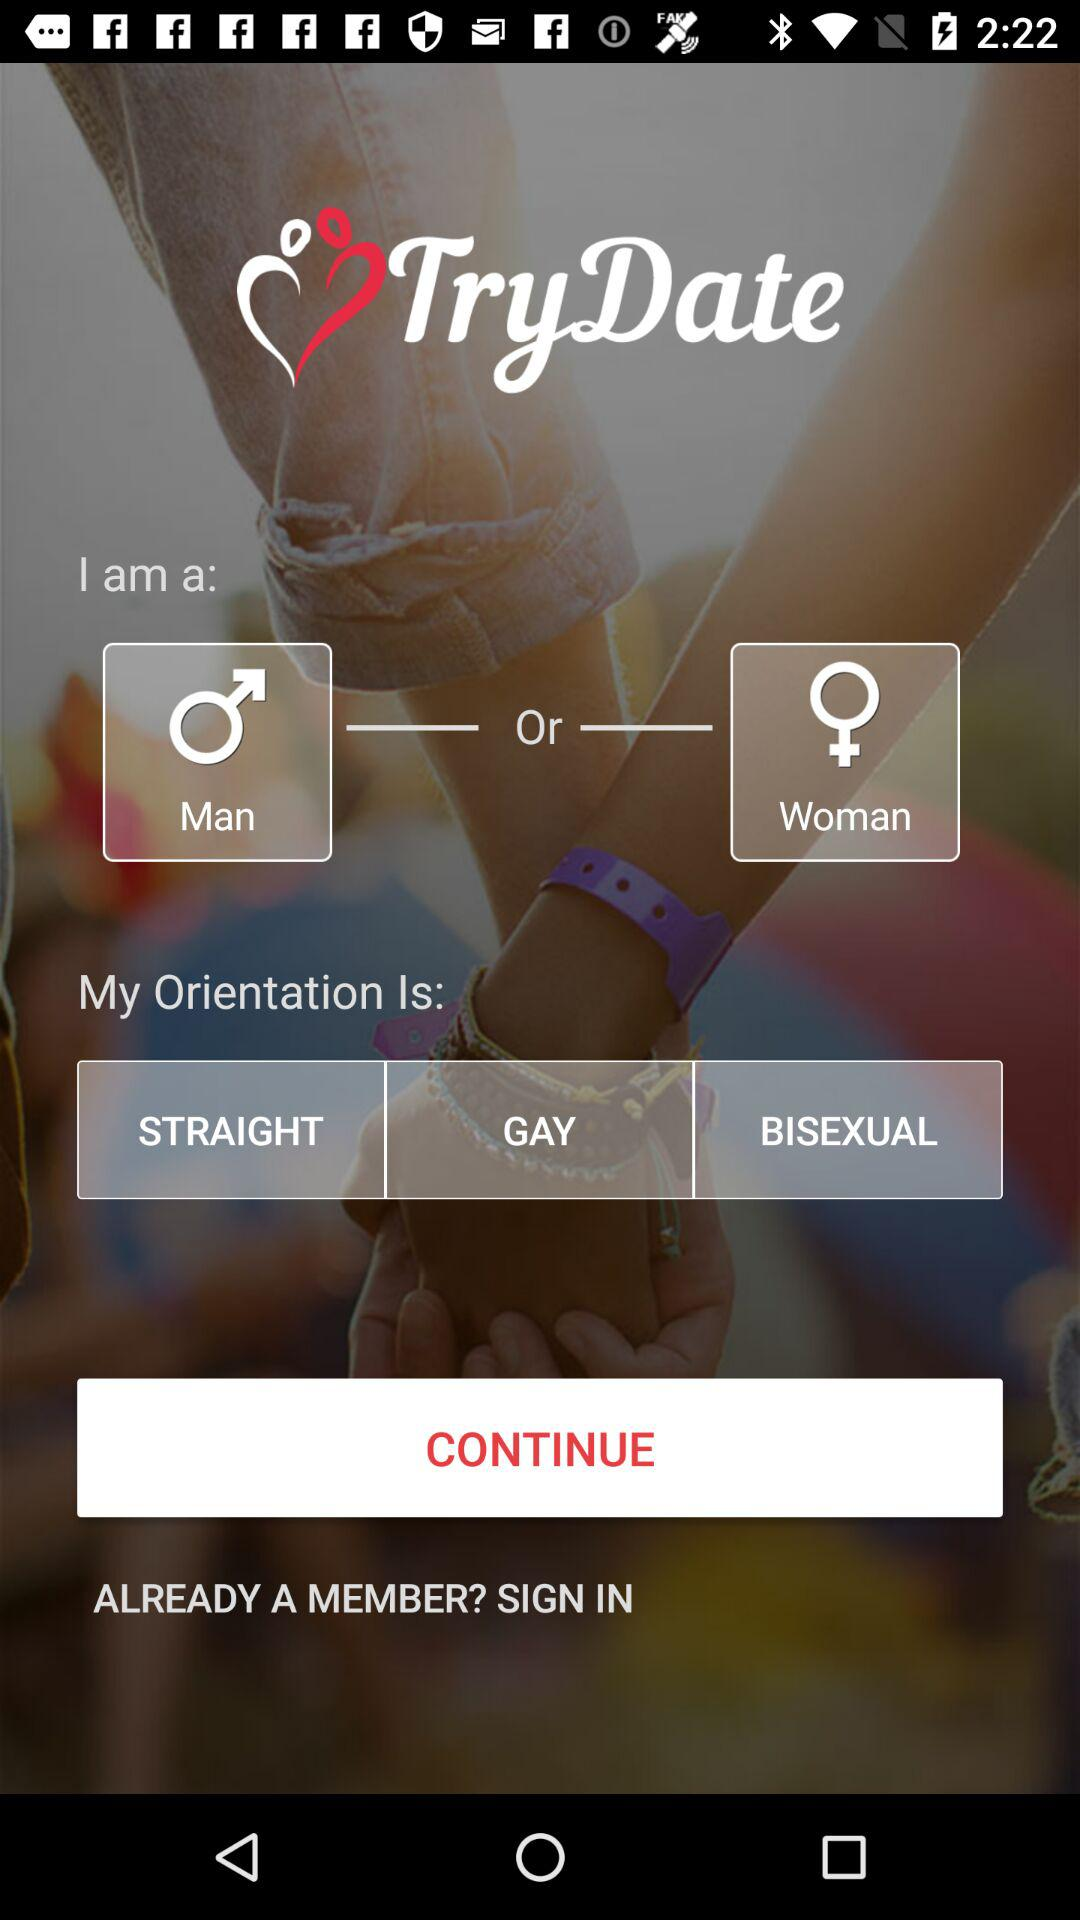What is the name of the application? The name of the application is "TryDate". 